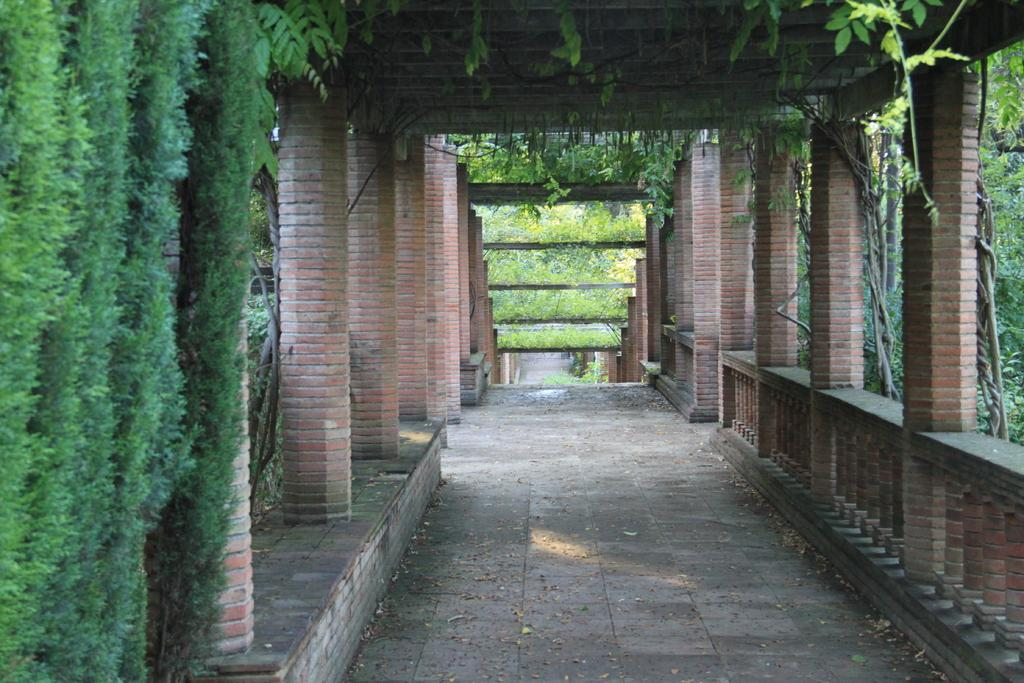What architectural features can be seen in the image? There are pillars, a wall, a railing, a floor, and a roof in the image. Can you describe the vegetation present in the image? Creepers are present on the left side of the image, and there are plants in the background of the image. How many chairs are visible in the image? There are no chairs present in the image. What type of beam is holding up the roof in the image? There is no beam visible in the image; only pillars are mentioned as supporting the structure. 